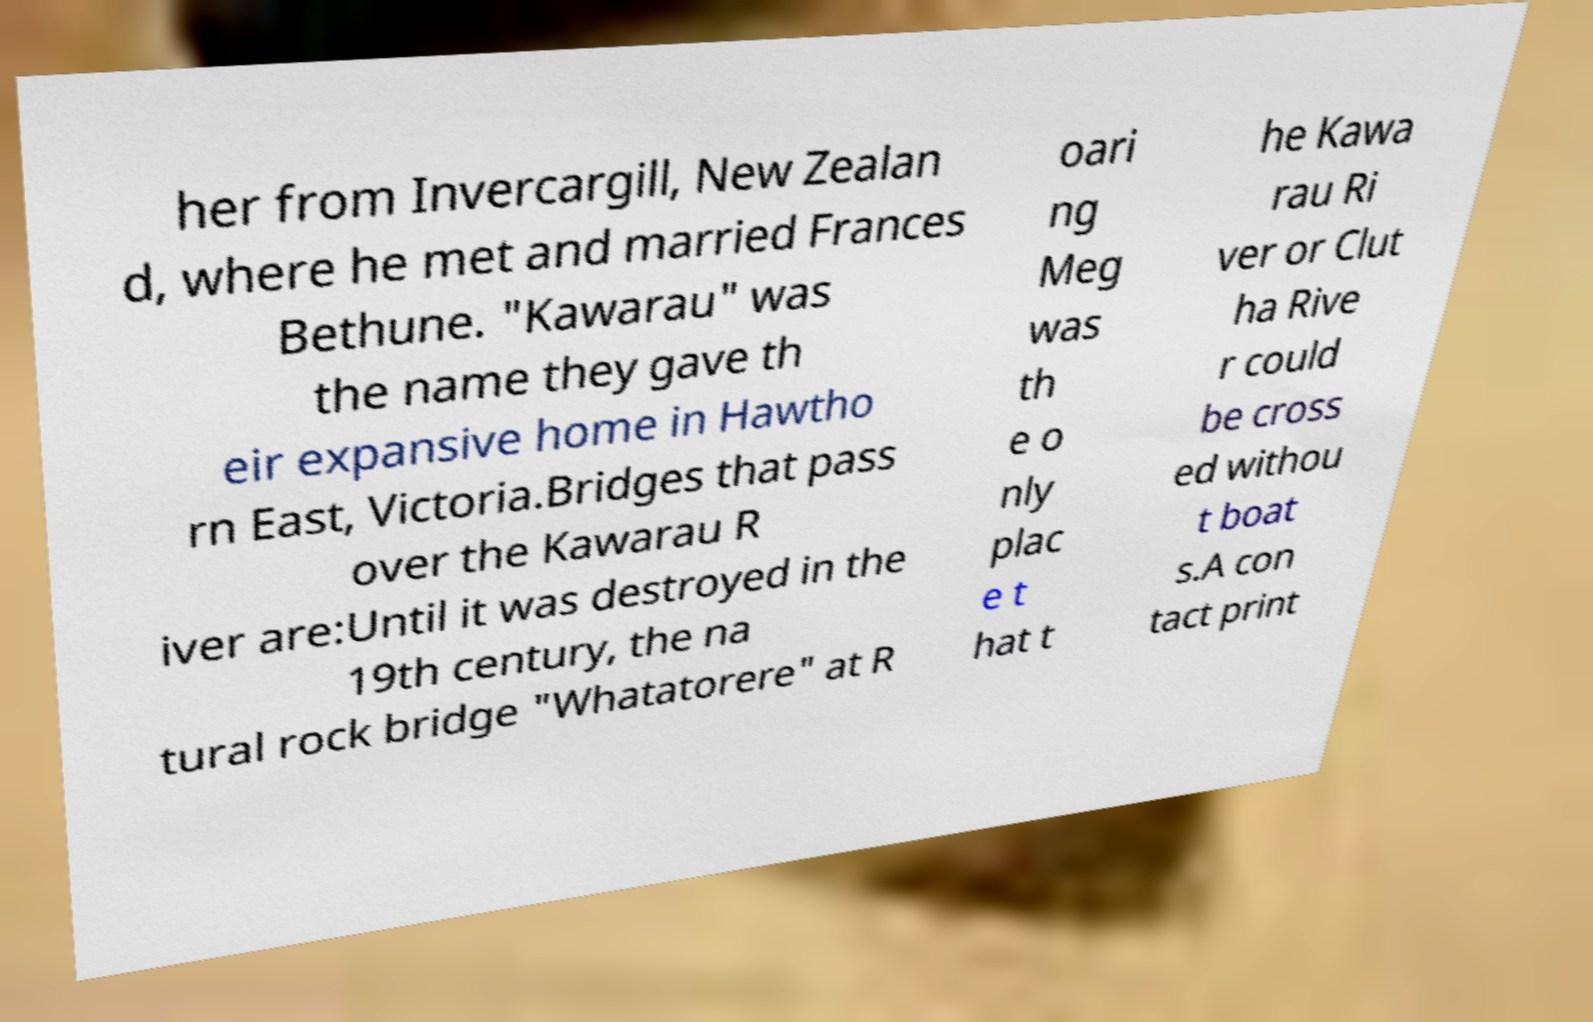Could you extract and type out the text from this image? her from Invercargill, New Zealan d, where he met and married Frances Bethune. "Kawarau" was the name they gave th eir expansive home in Hawtho rn East, Victoria.Bridges that pass over the Kawarau R iver are:Until it was destroyed in the 19th century, the na tural rock bridge "Whatatorere" at R oari ng Meg was th e o nly plac e t hat t he Kawa rau Ri ver or Clut ha Rive r could be cross ed withou t boat s.A con tact print 